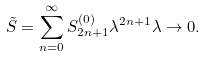<formula> <loc_0><loc_0><loc_500><loc_500>\tilde { S } = \sum _ { n = 0 } ^ { \infty } S _ { 2 n + 1 } ^ { ( 0 ) } \lambda ^ { 2 n + 1 } \lambda \rightarrow 0 .</formula> 